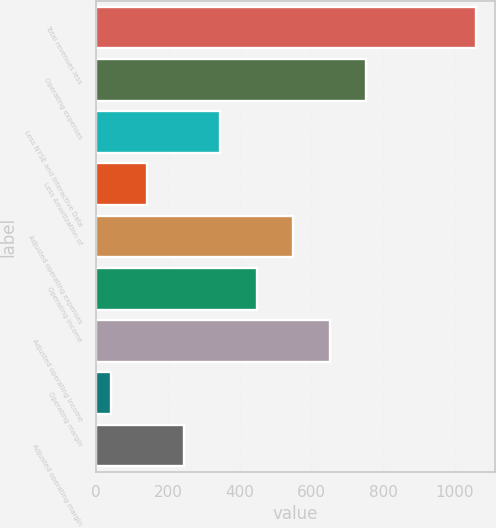<chart> <loc_0><loc_0><loc_500><loc_500><bar_chart><fcel>Total revenues less<fcel>Operating expenses<fcel>Less NYSE and Interactive Data<fcel>Less Amortization of<fcel>Adjusted operating expenses<fcel>Operating income<fcel>Adjusted operating income<fcel>Operating margin<fcel>Adjusted operating margin<nl><fcel>1058<fcel>752.6<fcel>345.4<fcel>141.8<fcel>549<fcel>447.2<fcel>650.8<fcel>40<fcel>243.6<nl></chart> 